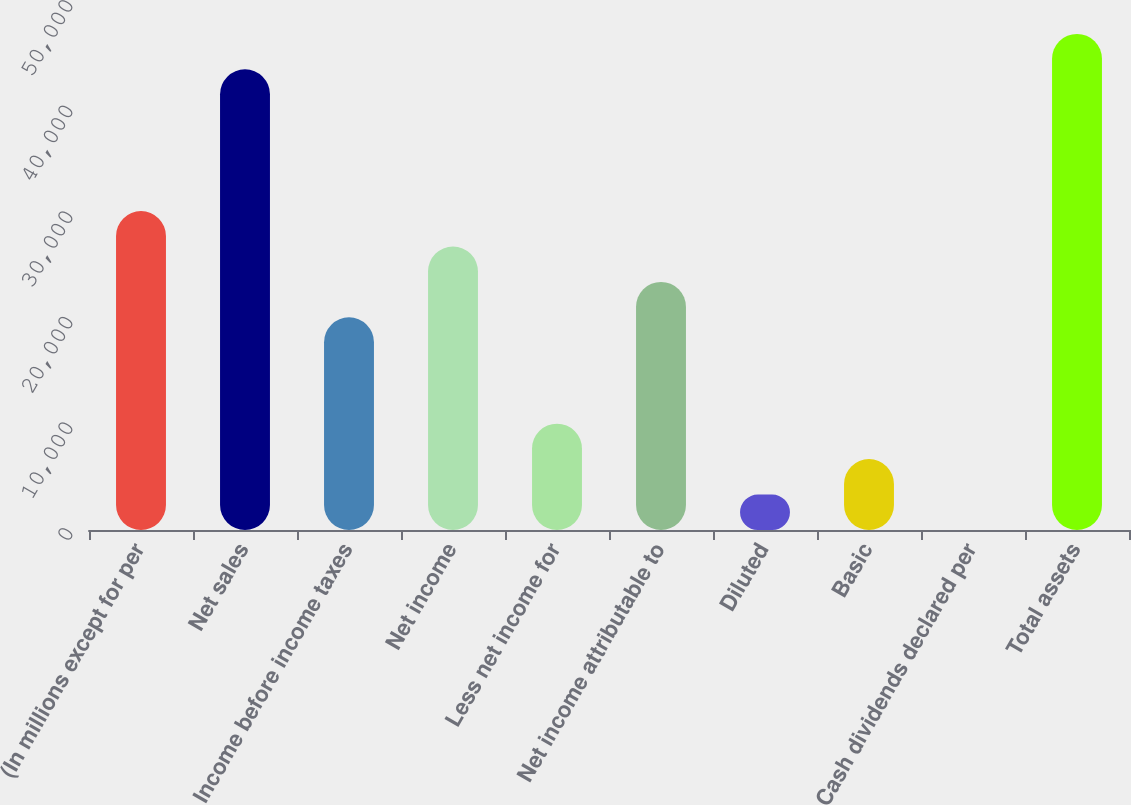Convert chart. <chart><loc_0><loc_0><loc_500><loc_500><bar_chart><fcel>(In millions except for per<fcel>Net sales<fcel>Income before income taxes<fcel>Net income<fcel>Less net income for<fcel>Net income attributable to<fcel>Diluted<fcel>Basic<fcel>Cash dividends declared per<fcel>Total assets<nl><fcel>30201.5<fcel>43623.5<fcel>20135<fcel>26846<fcel>10068.5<fcel>23490.5<fcel>3357.46<fcel>6712.96<fcel>1.96<fcel>46979<nl></chart> 